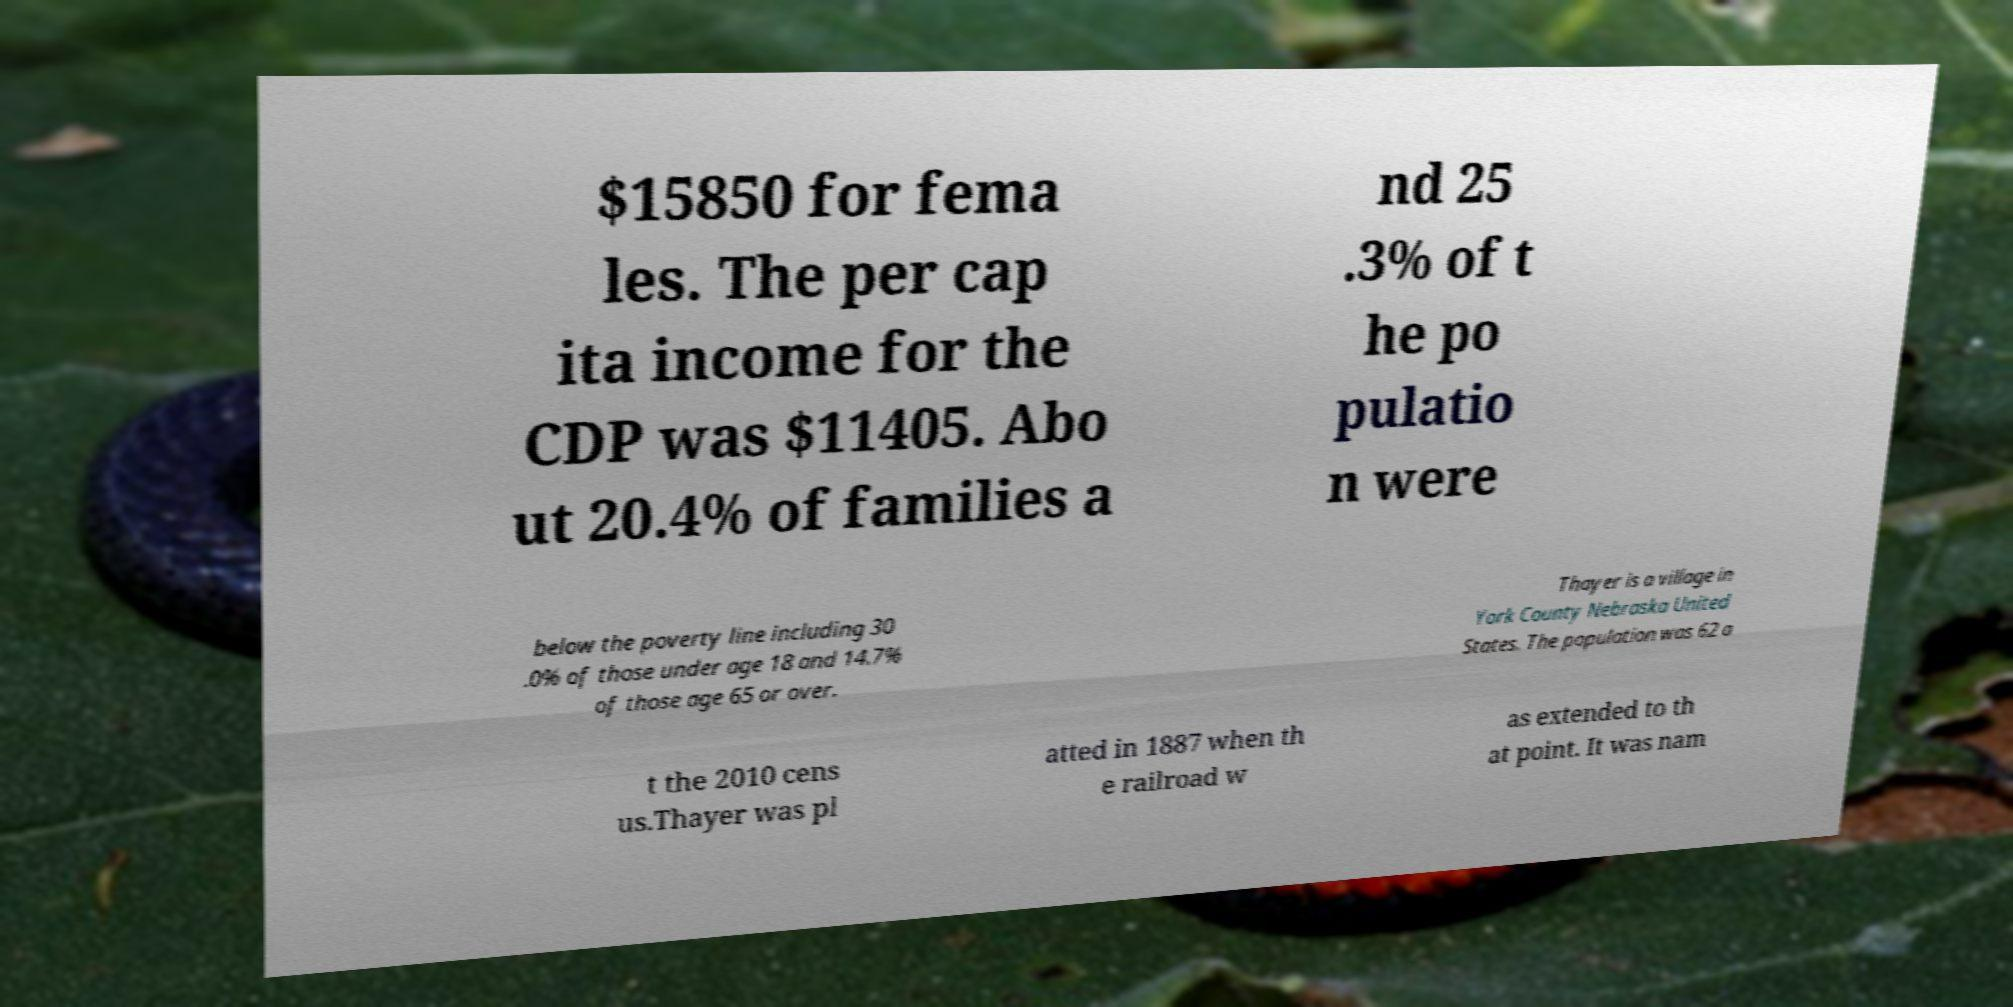Please read and relay the text visible in this image. What does it say? $15850 for fema les. The per cap ita income for the CDP was $11405. Abo ut 20.4% of families a nd 25 .3% of t he po pulatio n were below the poverty line including 30 .0% of those under age 18 and 14.7% of those age 65 or over. Thayer is a village in York County Nebraska United States. The population was 62 a t the 2010 cens us.Thayer was pl atted in 1887 when th e railroad w as extended to th at point. It was nam 